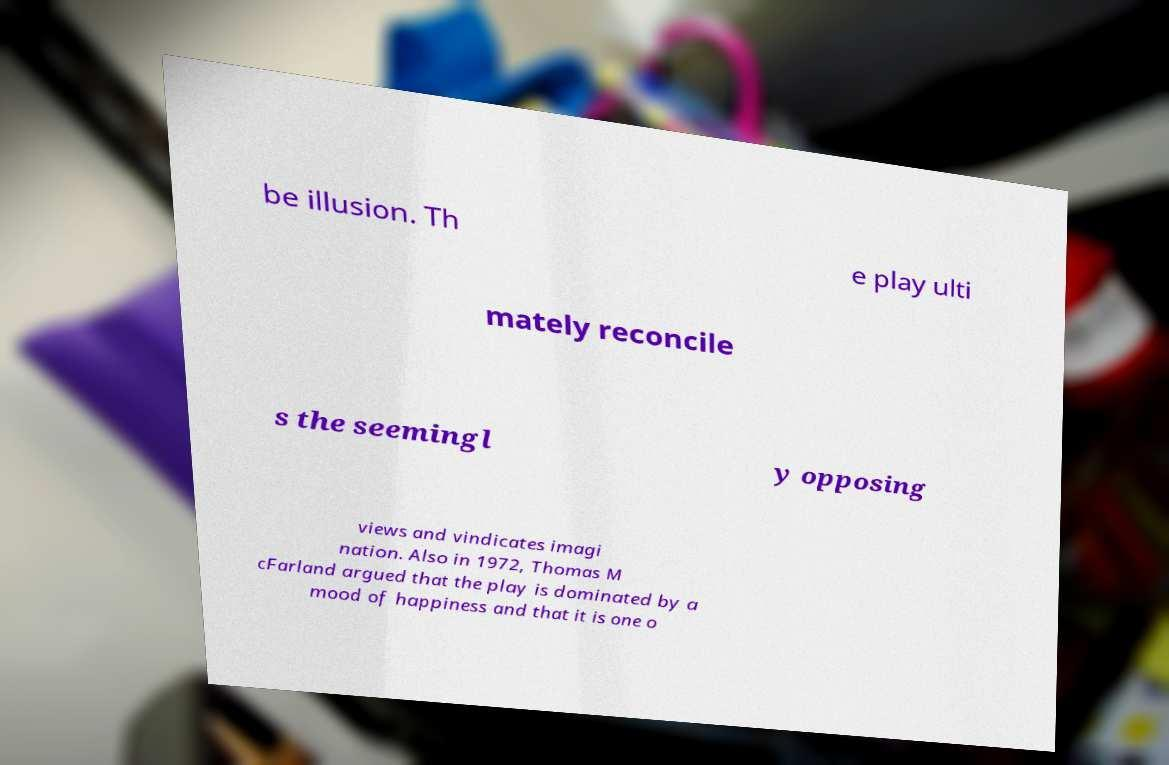There's text embedded in this image that I need extracted. Can you transcribe it verbatim? be illusion. Th e play ulti mately reconcile s the seemingl y opposing views and vindicates imagi nation. Also in 1972, Thomas M cFarland argued that the play is dominated by a mood of happiness and that it is one o 